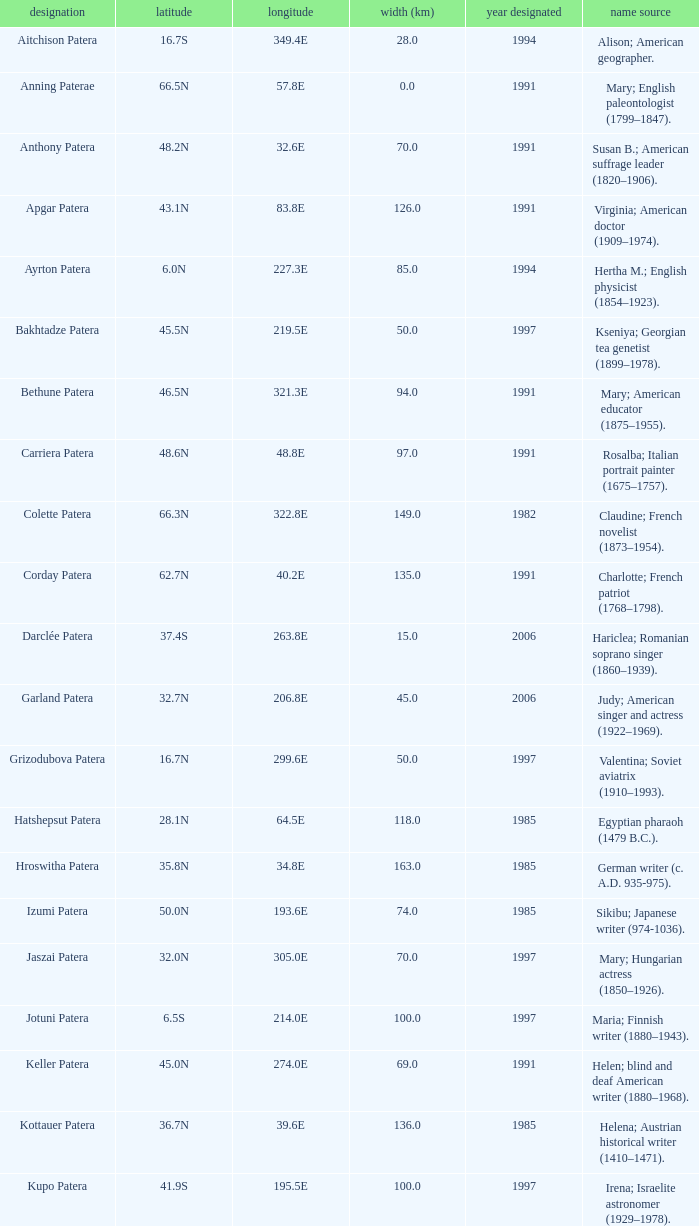What is  the diameter in km of the feature with a longitude of 40.2E?  135.0. 